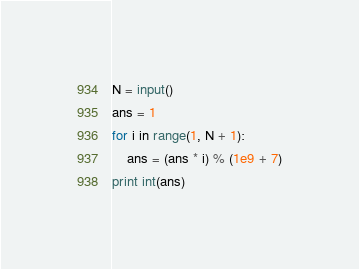Convert code to text. <code><loc_0><loc_0><loc_500><loc_500><_Python_>N = input()
ans = 1
for i in range(1, N + 1):
	ans = (ans * i) % (1e9 + 7)
print int(ans)</code> 